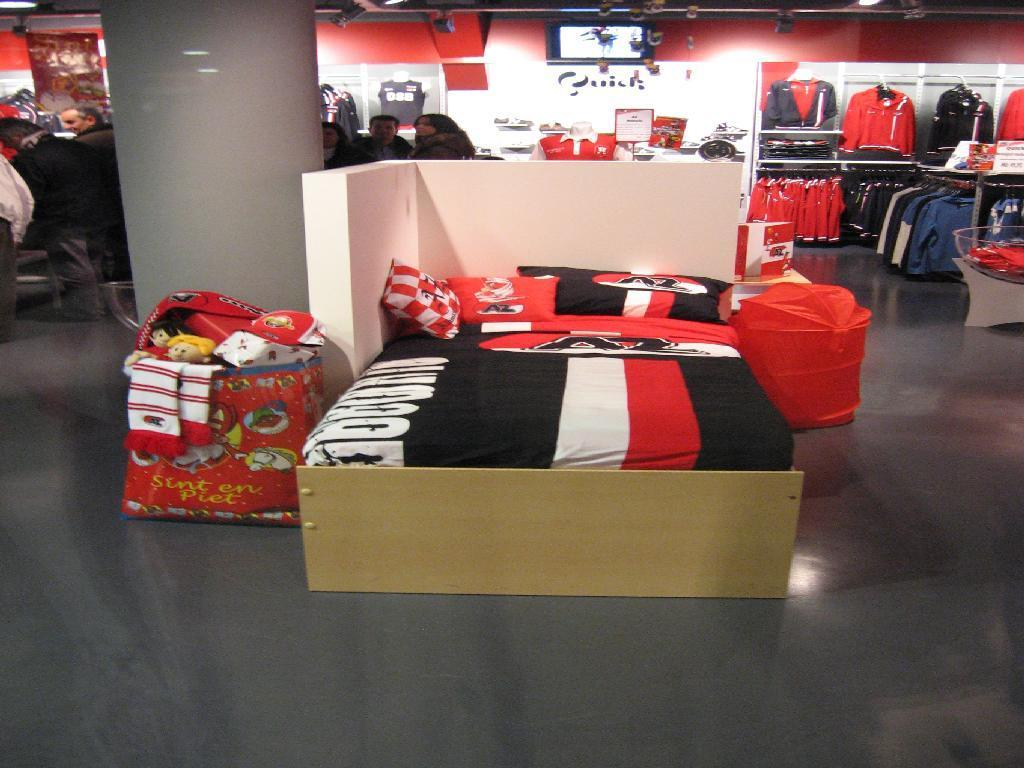What is on the floor in the image? There is a bed on the floor in the image. What is on top of the bed? There are pillows, toys, and a bag on the bed. What objects can be seen in the room? There is a pillar, clothes, a board, a mannequin, and a screen in the room. How many people are in the room? There are persons in the room. What is visible in the background of the image? There is a wall in the background of the image. What time of day is it in the image, and is there any shade provided? The time of day and presence of shade cannot be determined from the image, as it does not provide any information about the lighting or time of day. 